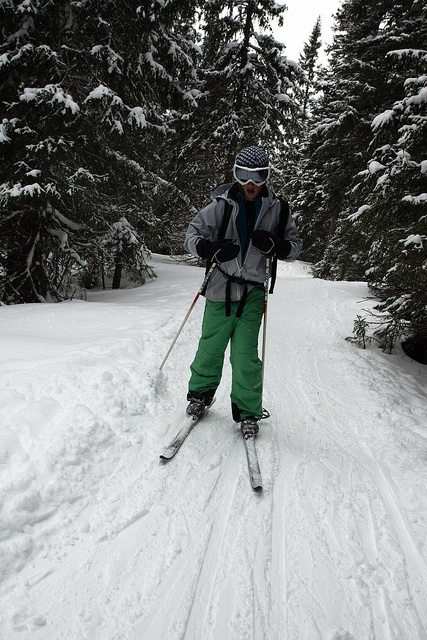Describe the objects in this image and their specific colors. I can see people in gray, black, and darkgreen tones and skis in gray, darkgray, lightgray, and black tones in this image. 